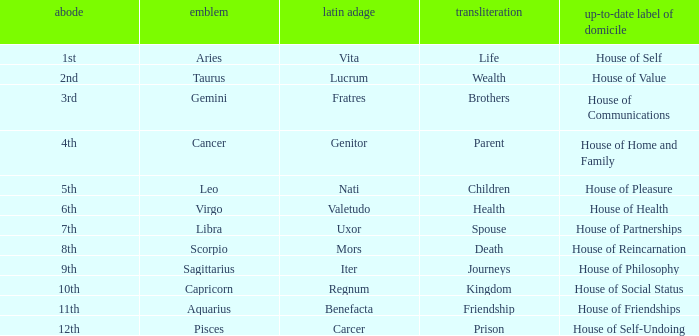What is the modern house title of the 1st house? House of Self. 